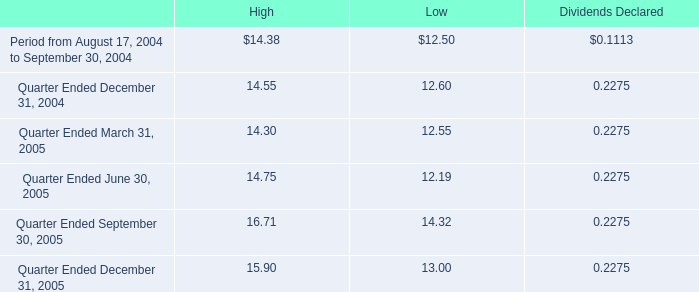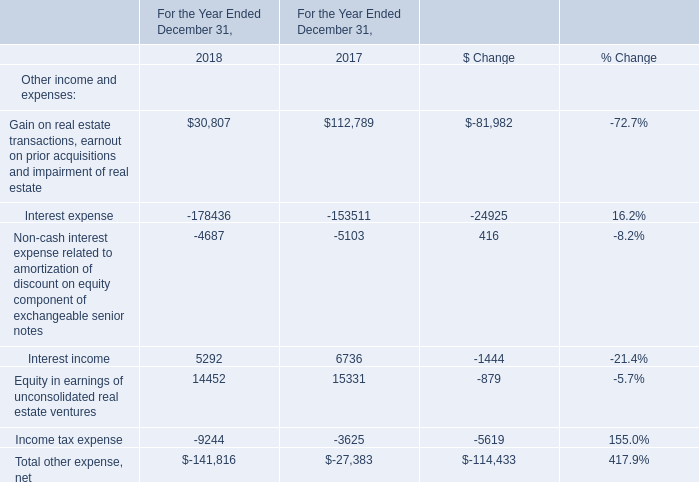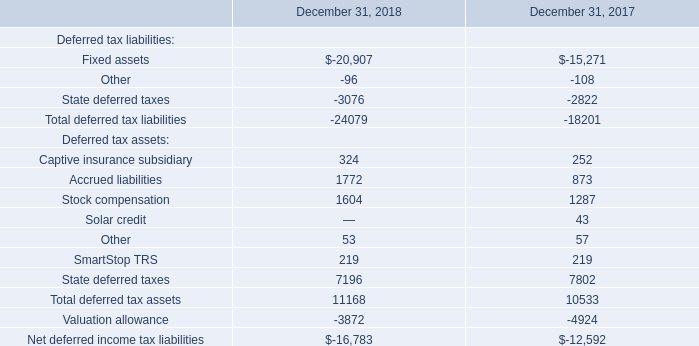using the high bid price what was the percentage difference between the quarter ended december 31 , 2004 and the quarter ended march 312005? 
Computations: ((14.30 - 14.55) / 14.55)
Answer: -0.01718. 